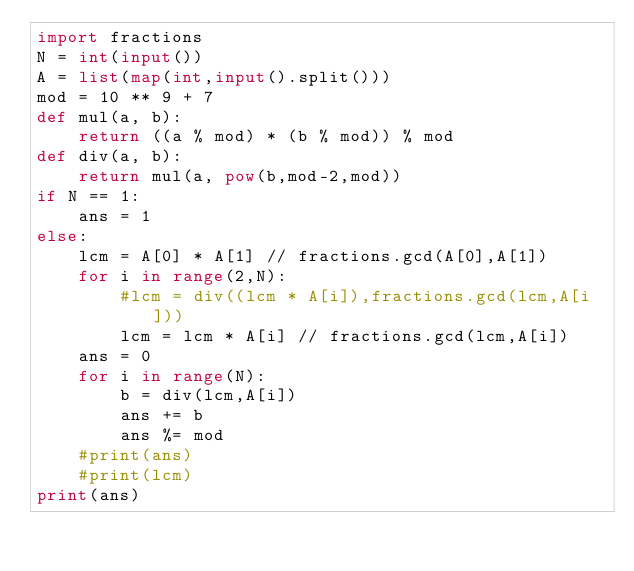Convert code to text. <code><loc_0><loc_0><loc_500><loc_500><_Python_>import fractions
N = int(input())
A = list(map(int,input().split()))
mod = 10 ** 9 + 7
def mul(a, b):
    return ((a % mod) * (b % mod)) % mod
def div(a, b):
    return mul(a, pow(b,mod-2,mod))
if N == 1:
    ans = 1
else:
    lcm = A[0] * A[1] // fractions.gcd(A[0],A[1])
    for i in range(2,N):
        #lcm = div((lcm * A[i]),fractions.gcd(lcm,A[i]))
        lcm = lcm * A[i] // fractions.gcd(lcm,A[i])
    ans = 0
    for i in range(N):
        b = div(lcm,A[i])
        ans += b 
        ans %= mod 
    #print(ans)
    #print(lcm)
print(ans)
</code> 